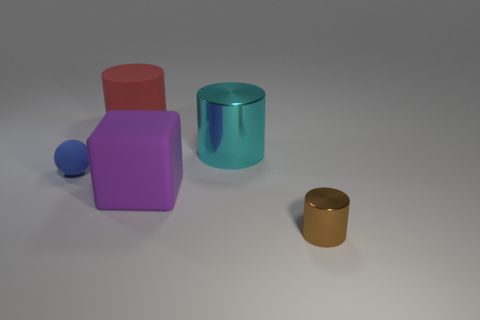What can you infer about the size relationships among the objects? The red cube appears to be the largest object, followed by the cyan cylinder. The gold cylinder is the smallest, and the blue sphere is smaller than the cyan cylinder but larger than the gold cylinder. 